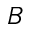<formula> <loc_0><loc_0><loc_500><loc_500>B</formula> 